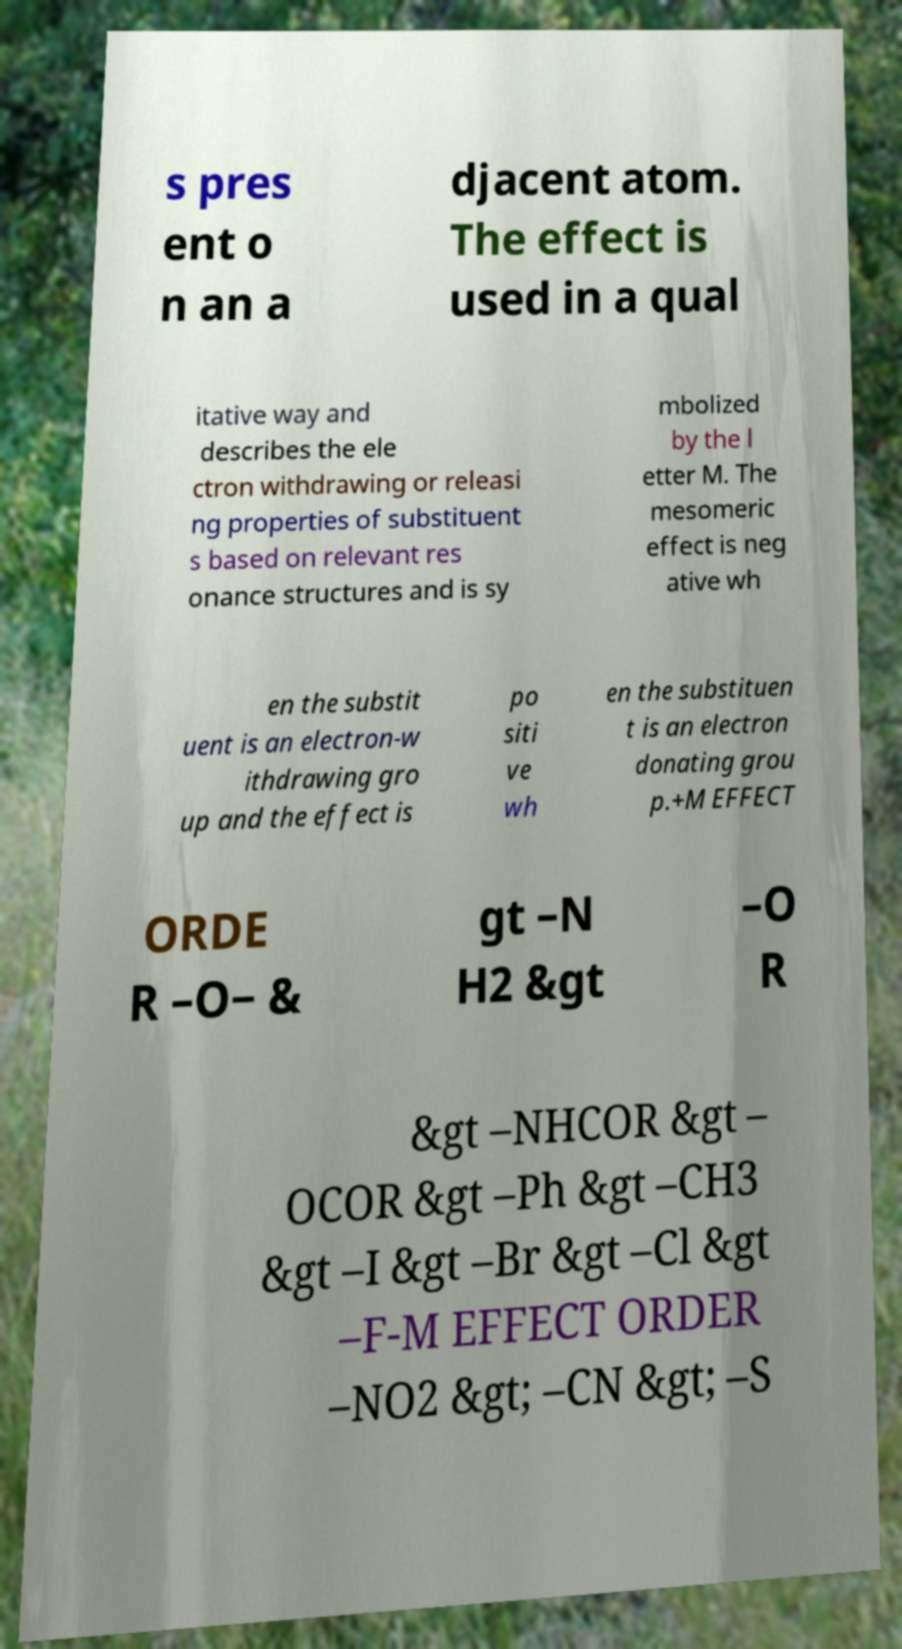Can you read and provide the text displayed in the image?This photo seems to have some interesting text. Can you extract and type it out for me? s pres ent o n an a djacent atom. The effect is used in a qual itative way and describes the ele ctron withdrawing or releasi ng properties of substituent s based on relevant res onance structures and is sy mbolized by the l etter M. The mesomeric effect is neg ative wh en the substit uent is an electron-w ithdrawing gro up and the effect is po siti ve wh en the substituen t is an electron donating grou p.+M EFFECT ORDE R –O− & gt –N H2 &gt –O R &gt –NHCOR &gt – OCOR &gt –Ph &gt –CH3 &gt –I &gt –Br &gt –Cl &gt –F-M EFFECT ORDER –NO2 &gt; –CN &gt; –S 